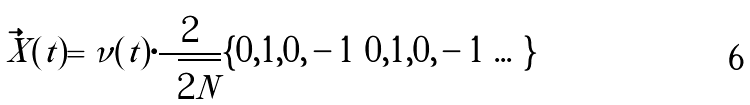Convert formula to latex. <formula><loc_0><loc_0><loc_500><loc_500>\vec { X } ( t ) = \nu ( t ) \cdot \frac { 2 } { \sqrt { 2 N } } \{ 0 , 1 , 0 , - 1 \, | \, 0 , 1 , 0 , - 1 \, | \dots \}</formula> 